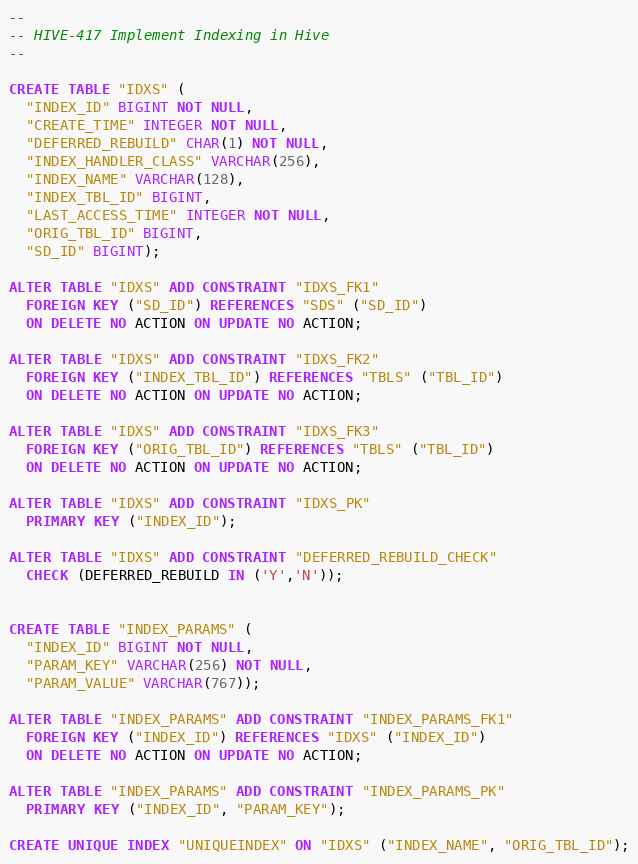<code> <loc_0><loc_0><loc_500><loc_500><_SQL_>--
-- HIVE-417 Implement Indexing in Hive
--

CREATE TABLE "IDXS" (
  "INDEX_ID" BIGINT NOT NULL,
  "CREATE_TIME" INTEGER NOT NULL,
  "DEFERRED_REBUILD" CHAR(1) NOT NULL,
  "INDEX_HANDLER_CLASS" VARCHAR(256),
  "INDEX_NAME" VARCHAR(128),
  "INDEX_TBL_ID" BIGINT,
  "LAST_ACCESS_TIME" INTEGER NOT NULL,
  "ORIG_TBL_ID" BIGINT,
  "SD_ID" BIGINT);

ALTER TABLE "IDXS" ADD CONSTRAINT "IDXS_FK1"
  FOREIGN KEY ("SD_ID") REFERENCES "SDS" ("SD_ID")
  ON DELETE NO ACTION ON UPDATE NO ACTION;

ALTER TABLE "IDXS" ADD CONSTRAINT "IDXS_FK2"
  FOREIGN KEY ("INDEX_TBL_ID") REFERENCES "TBLS" ("TBL_ID")
  ON DELETE NO ACTION ON UPDATE NO ACTION;

ALTER TABLE "IDXS" ADD CONSTRAINT "IDXS_FK3"
  FOREIGN KEY ("ORIG_TBL_ID") REFERENCES "TBLS" ("TBL_ID")
  ON DELETE NO ACTION ON UPDATE NO ACTION;

ALTER TABLE "IDXS" ADD CONSTRAINT "IDXS_PK"
  PRIMARY KEY ("INDEX_ID");

ALTER TABLE "IDXS" ADD CONSTRAINT "DEFERRED_REBUILD_CHECK"
  CHECK (DEFERRED_REBUILD IN ('Y','N'));


CREATE TABLE "INDEX_PARAMS" (
  "INDEX_ID" BIGINT NOT NULL,
  "PARAM_KEY" VARCHAR(256) NOT NULL,
  "PARAM_VALUE" VARCHAR(767));

ALTER TABLE "INDEX_PARAMS" ADD CONSTRAINT "INDEX_PARAMS_FK1"
  FOREIGN KEY ("INDEX_ID") REFERENCES "IDXS" ("INDEX_ID")
  ON DELETE NO ACTION ON UPDATE NO ACTION;

ALTER TABLE "INDEX_PARAMS" ADD CONSTRAINT "INDEX_PARAMS_PK"
  PRIMARY KEY ("INDEX_ID", "PARAM_KEY");

CREATE UNIQUE INDEX "UNIQUEINDEX" ON "IDXS" ("INDEX_NAME", "ORIG_TBL_ID");
</code> 